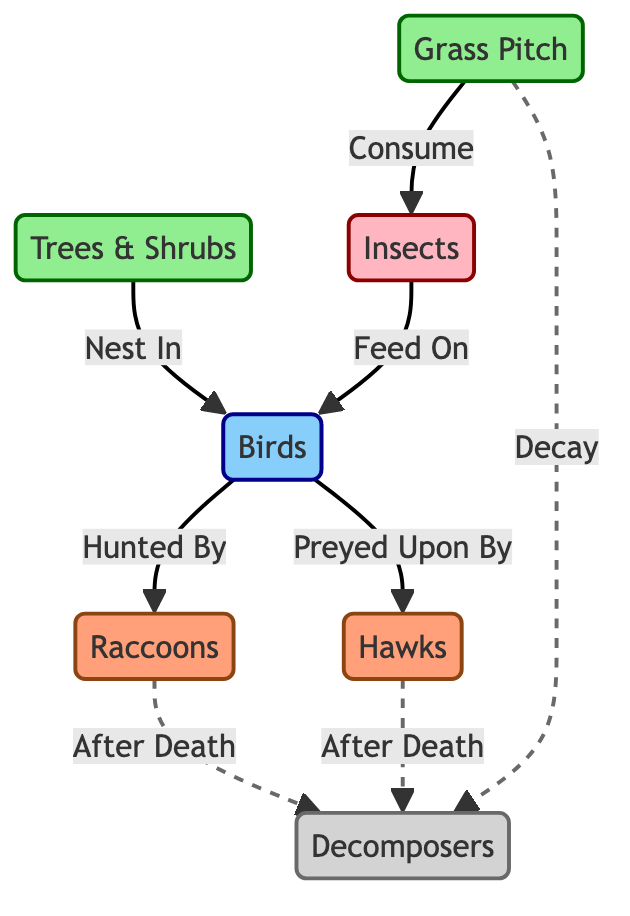What are the producers in the diagram? The producers are indicated by the nodes at the beginning of the food chain, which are the Grass Pitch and Trees & Shrubs. Both of these are foundational elements that generate energy for the ecosystem.
Answer: Grass Pitch, Trees & Shrubs How many primary consumers are there in the diagram? To find the primary consumers, we look for the nodes that are directly connected to the producers and consume them. In this diagram, there's only one primary consumer, which is Insects.
Answer: 1 What animals prey upon birds? This question involves looking for connections to the Birds node and finding which entities hunt them. The diagram shows that Raccoons and Hawks prey upon Birds.
Answer: Raccoons, Hawks What is the relationship between grass and insects? The relationship can be found by examining the direct arrows from Grass Pitch to Insects. The arrow indicates that insects consume grass.
Answer: Consume How do decomposers interact with raccoons in the diagram? The interaction is shown as a dashed line from Raccoons to Decomposers. This indicates that after raccoons die, they are decomposed, which is a form of nutrient recycling in the ecosystem.
Answer: After Death Which organisms are classified as tertiary consumers? Tertiary consumers are typically those that are at the top of the food chain and feed on secondary consumers. In this diagram, both Raccoons and Hawks are classified as tertiary consumers.
Answer: Raccoons, Hawks What is the connection between Trees & Shrubs and Birds? There is a direct relationship where Birds nest in Trees & Shrubs, indicated by the arrow pointing from Trees & Shrubs to Birds.
Answer: Nest In How do hawks obtain food in this ecosystem? The diagram shows that Hawks prey on Birds, which serves as their food source. Therefore, their primary food acquisition method involves hunting Birds.
Answer: Preyed Upon By What happens to grass after decay according to the diagram? The diagram shows that after decay, Grass contributes to the nutritional cycle by feeding into the Decomposers, represented as a dashed line. This indicates that decay leads to decomposition.
Answer: Decay 